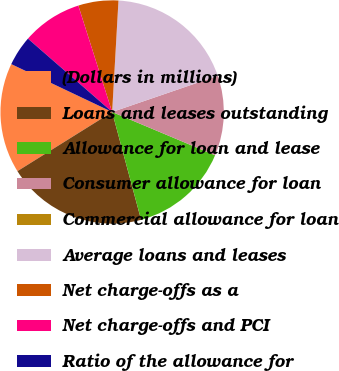Convert chart to OTSL. <chart><loc_0><loc_0><loc_500><loc_500><pie_chart><fcel>(Dollars in millions)<fcel>Loans and leases outstanding<fcel>Allowance for loan and lease<fcel>Consumer allowance for loan<fcel>Commercial allowance for loan<fcel>Average loans and leases<fcel>Net charge-offs as a<fcel>Net charge-offs and PCI<fcel>Ratio of the allowance for<nl><fcel>15.94%<fcel>20.29%<fcel>14.49%<fcel>11.59%<fcel>0.0%<fcel>18.84%<fcel>5.8%<fcel>8.7%<fcel>4.35%<nl></chart> 